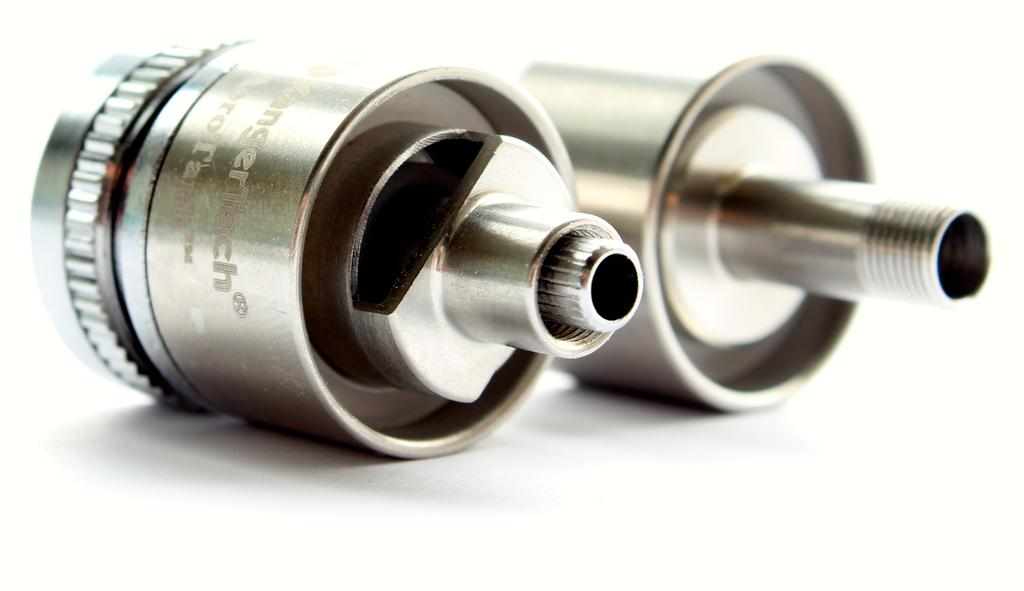What can be seen in the image? There are objects visible in the image. Can you describe the location of the objects in the image? The objects are placed on a surface. What type of ice can be seen melting on the objects in the image? There is no ice visible in the image, and therefore no ice can be seen melting on the objects. How many legs are supporting the objects in the image? The provided facts do not mention any legs supporting the objects, so it is not possible to determine the number of legs. 